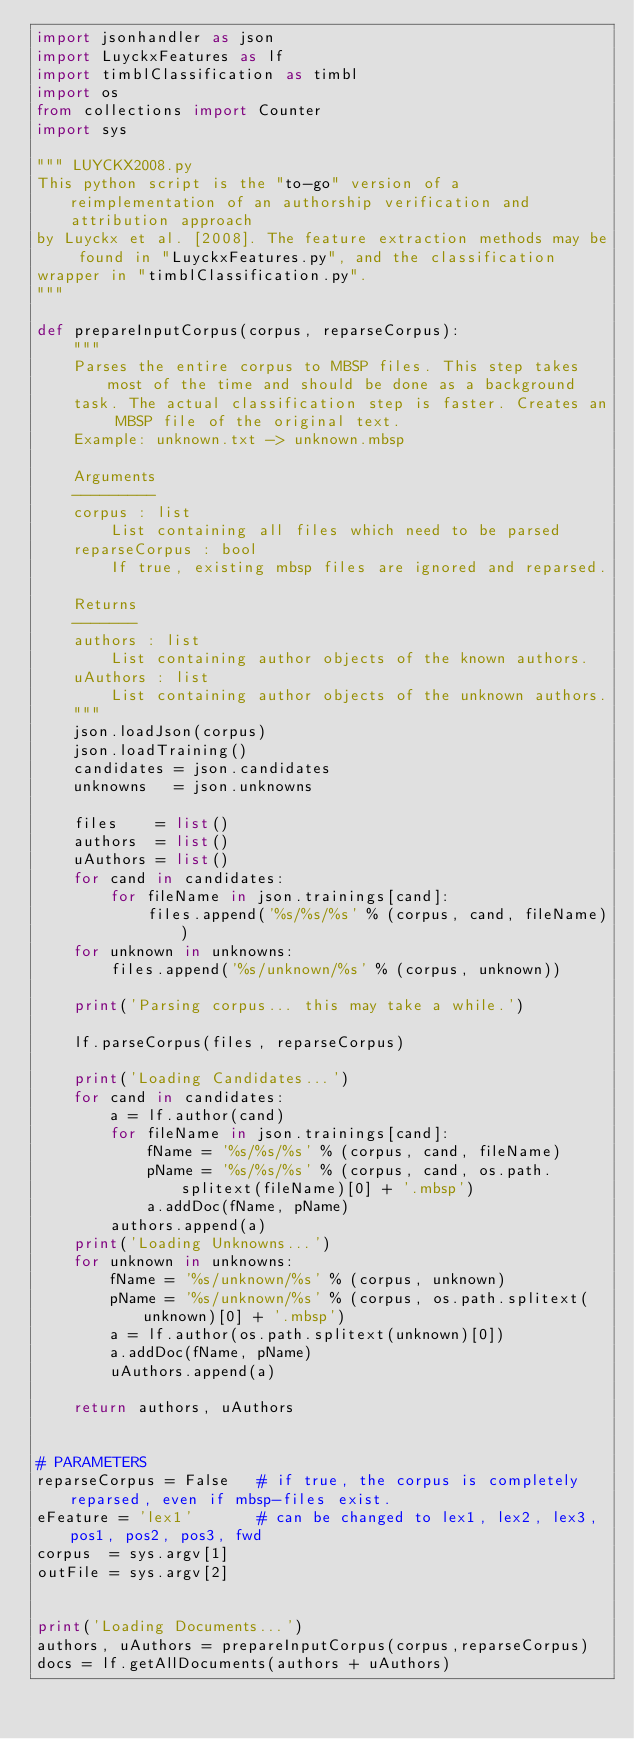<code> <loc_0><loc_0><loc_500><loc_500><_Python_>import jsonhandler as json
import LuyckxFeatures as lf
import timblClassification as timbl
import os
from collections import Counter
import sys

""" LUYCKX2008.py
This python script is the "to-go" version of a reimplementation of an authorship verification and attribution approach 
by Luyckx et al. [2008]. The feature extraction methods may be found in "LuyckxFeatures.py", and the classification 
wrapper in "timblClassification.py".
"""

def prepareInputCorpus(corpus, reparseCorpus):
    """
    Parses the entire corpus to MBSP files. This step takes most of the time and should be done as a background
    task. The actual classification step is faster. Creates an MBSP file of the original text.
    Example: unknown.txt -> unknown.mbsp

    Arguments
    ---------
    corpus : list
        List containing all files which need to be parsed
    reparseCorpus : bool
        If true, existing mbsp files are ignored and reparsed.

    Returns
    -------
    authors : list
        List containing author objects of the known authors.
    uAuthors : list
        List containing author objects of the unknown authors.
    """
    json.loadJson(corpus)
    json.loadTraining()
    candidates = json.candidates
    unknowns   = json.unknowns

    files    = list()
    authors  = list()
    uAuthors = list()
    for cand in candidates:
        for fileName in json.trainings[cand]:
            files.append('%s/%s/%s' % (corpus, cand, fileName))
    for unknown in unknowns:
        files.append('%s/unknown/%s' % (corpus, unknown))

    print('Parsing corpus... this may take a while.')

    lf.parseCorpus(files, reparseCorpus)

    print('Loading Candidates...')
    for cand in candidates:
        a = lf.author(cand)
        for fileName in json.trainings[cand]:
            fName = '%s/%s/%s' % (corpus, cand, fileName)
            pName = '%s/%s/%s' % (corpus, cand, os.path.splitext(fileName)[0] + '.mbsp')
            a.addDoc(fName, pName)
        authors.append(a)
    print('Loading Unknowns...')
    for unknown in unknowns:
        fName = '%s/unknown/%s' % (corpus, unknown)
        pName = '%s/unknown/%s' % (corpus, os.path.splitext(unknown)[0] + '.mbsp')
        a = lf.author(os.path.splitext(unknown)[0])
        a.addDoc(fName, pName)
        uAuthors.append(a)

    return authors, uAuthors


# PARAMETERS
reparseCorpus = False   # if true, the corpus is completely reparsed, even if mbsp-files exist.
eFeature = 'lex1'       # can be changed to lex1, lex2, lex3, pos1, pos2, pos3, fwd
corpus  = sys.argv[1]
outFile = sys.argv[2]


print('Loading Documents...')
authors, uAuthors = prepareInputCorpus(corpus,reparseCorpus)
docs = lf.getAllDocuments(authors + uAuthors)</code> 